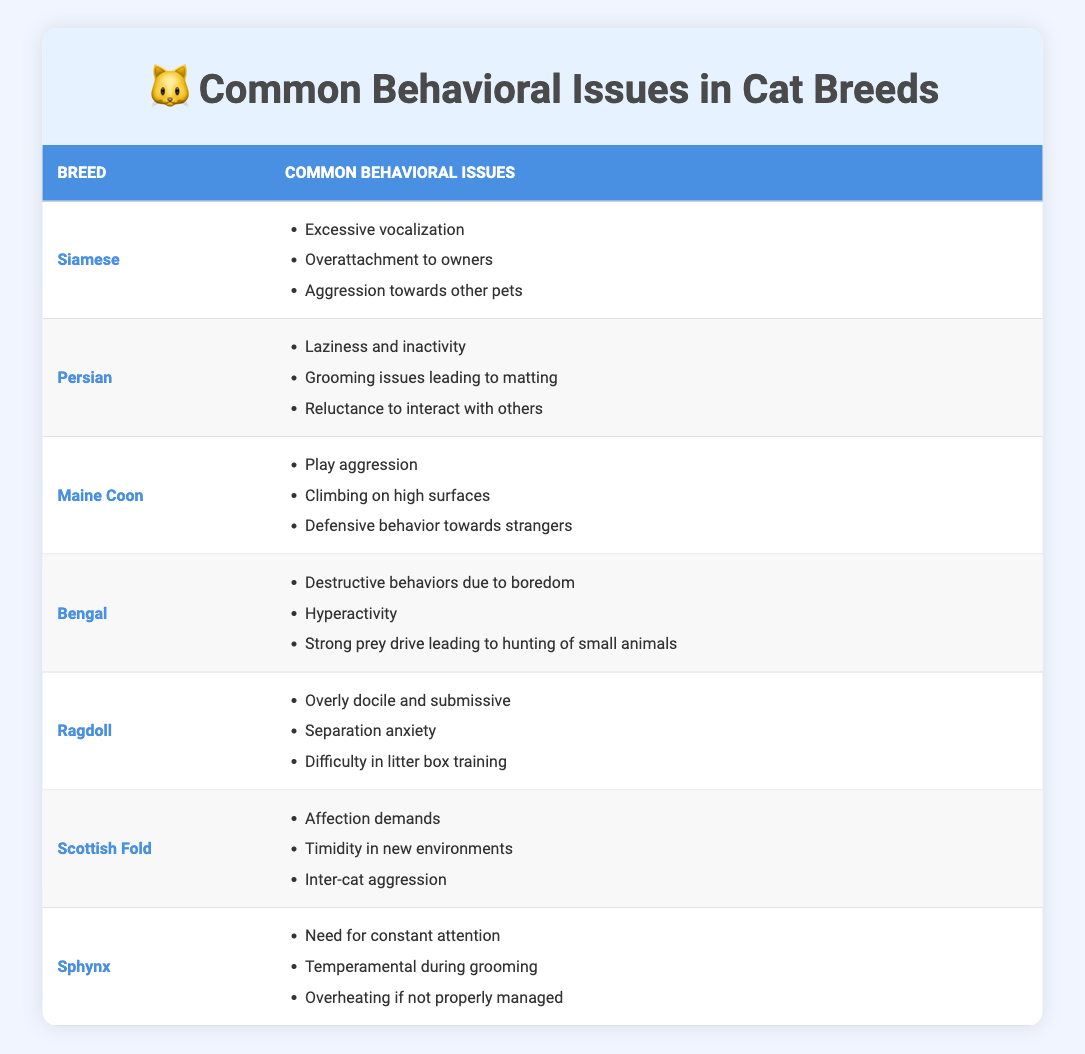What are the common behavioral issues observed in Siamese cats? The table lists common behavioral issues for different cat breeds. For Siamese cats specifically, the issues noted are excessive vocalization, overattachment to owners, and aggression towards other pets.
Answer: Excessive vocalization, overattachment to owners, aggression towards other pets How many common behavioral issues are listed for the Maine Coon breed? The table indicates three behavioral issues for Maine Coon cats: play aggression, climbing on high surfaces, and defensive behavior towards strangers. Counting these gives us a total of three issues.
Answer: 3 Do Bengal cats demonstrate destructive behaviors due to boredom? The table includes destructive behaviors due to boredom as a common behavioral issue for Bengal cats, indicating that they do exhibit this behavior.
Answer: Yes Which breed shows the highest number of behavioral issues related to social interactions? By examining the list, we see that both Siamese and Scottish Fold breeds have behavioral issues involving social interactions. Siamese cats have issues with aggression towards other pets while Scottish Folds experience inter-cat aggression and timidity in new environments. However, Scottish Fold has a total of three social interaction issues, making it the highest.
Answer: Scottish Fold Are Ragdolls likely to experience separation anxiety? The table states that Ragdoll cats have separation anxiety listed as one of their common behavioral issues, confirming that they are likely to experience this issue.
Answer: Yes What is the average number of behavioral issues listed across all breeds? The table mentions a total of 2 to 3 behavioral issues for each breed, listed as follows: Siamese (3), Persian (3), Maine Coon (3), Bengal (3), Ragdoll (3), Scottish Fold (3), and Sphynx (3). Adding these gives 21 issues. Since there are 7 breeds, the average is 21/7 = 3.
Answer: 3 Do Sphynx cats require constant attention? According to the table, Sphynx cats have a need for constant attention noted among their behavioral issues, indicating that this is indeed the case for this breed.
Answer: Yes Which breed has issues with both grooming and interaction with others? Persian cats are identified in the table as having grooming issues leading to matting, and reluctance to interact with others. Therefore, they show both behavioral concerns mentioned in the question.
Answer: Persian 